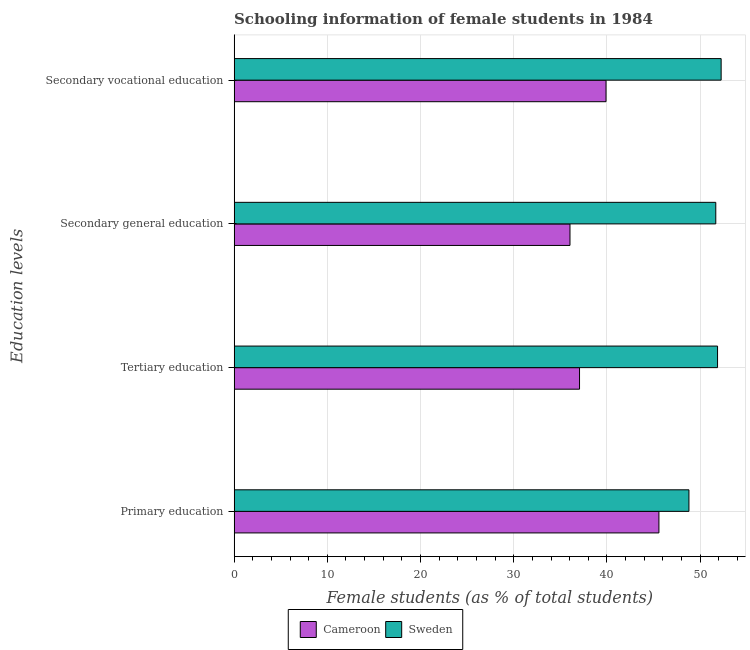How many different coloured bars are there?
Your response must be concise. 2. How many bars are there on the 1st tick from the top?
Offer a very short reply. 2. What is the label of the 2nd group of bars from the top?
Provide a succinct answer. Secondary general education. What is the percentage of female students in secondary vocational education in Cameroon?
Your answer should be very brief. 39.9. Across all countries, what is the maximum percentage of female students in primary education?
Ensure brevity in your answer.  48.8. Across all countries, what is the minimum percentage of female students in tertiary education?
Give a very brief answer. 37.06. In which country was the percentage of female students in tertiary education maximum?
Your response must be concise. Sweden. In which country was the percentage of female students in secondary vocational education minimum?
Offer a very short reply. Cameroon. What is the total percentage of female students in primary education in the graph?
Offer a terse response. 94.38. What is the difference between the percentage of female students in secondary education in Cameroon and that in Sweden?
Keep it short and to the point. -15.64. What is the difference between the percentage of female students in secondary vocational education in Cameroon and the percentage of female students in tertiary education in Sweden?
Keep it short and to the point. -11.96. What is the average percentage of female students in secondary education per country?
Give a very brief answer. 43.86. What is the difference between the percentage of female students in secondary vocational education and percentage of female students in tertiary education in Cameroon?
Your answer should be very brief. 2.84. In how many countries, is the percentage of female students in tertiary education greater than 36 %?
Keep it short and to the point. 2. What is the ratio of the percentage of female students in secondary education in Cameroon to that in Sweden?
Give a very brief answer. 0.7. What is the difference between the highest and the second highest percentage of female students in secondary education?
Your answer should be compact. 15.64. What is the difference between the highest and the lowest percentage of female students in secondary education?
Provide a short and direct response. 15.64. What does the 1st bar from the top in Tertiary education represents?
Provide a succinct answer. Sweden. What does the 1st bar from the bottom in Secondary general education represents?
Offer a terse response. Cameroon. Is it the case that in every country, the sum of the percentage of female students in primary education and percentage of female students in tertiary education is greater than the percentage of female students in secondary education?
Keep it short and to the point. Yes. How many bars are there?
Provide a short and direct response. 8. Are all the bars in the graph horizontal?
Provide a succinct answer. Yes. What is the difference between two consecutive major ticks on the X-axis?
Your answer should be compact. 10. Does the graph contain any zero values?
Provide a short and direct response. No. What is the title of the graph?
Your response must be concise. Schooling information of female students in 1984. What is the label or title of the X-axis?
Make the answer very short. Female students (as % of total students). What is the label or title of the Y-axis?
Provide a succinct answer. Education levels. What is the Female students (as % of total students) of Cameroon in Primary education?
Offer a very short reply. 45.58. What is the Female students (as % of total students) of Sweden in Primary education?
Your answer should be compact. 48.8. What is the Female students (as % of total students) of Cameroon in Tertiary education?
Your answer should be compact. 37.06. What is the Female students (as % of total students) of Sweden in Tertiary education?
Ensure brevity in your answer.  51.87. What is the Female students (as % of total students) of Cameroon in Secondary general education?
Provide a short and direct response. 36.04. What is the Female students (as % of total students) in Sweden in Secondary general education?
Offer a very short reply. 51.68. What is the Female students (as % of total students) of Cameroon in Secondary vocational education?
Your answer should be very brief. 39.9. What is the Female students (as % of total students) of Sweden in Secondary vocational education?
Provide a short and direct response. 52.25. Across all Education levels, what is the maximum Female students (as % of total students) of Cameroon?
Your response must be concise. 45.58. Across all Education levels, what is the maximum Female students (as % of total students) in Sweden?
Keep it short and to the point. 52.25. Across all Education levels, what is the minimum Female students (as % of total students) of Cameroon?
Keep it short and to the point. 36.04. Across all Education levels, what is the minimum Female students (as % of total students) in Sweden?
Keep it short and to the point. 48.8. What is the total Female students (as % of total students) in Cameroon in the graph?
Provide a short and direct response. 158.58. What is the total Female students (as % of total students) of Sweden in the graph?
Your response must be concise. 204.6. What is the difference between the Female students (as % of total students) in Cameroon in Primary education and that in Tertiary education?
Your answer should be compact. 8.52. What is the difference between the Female students (as % of total students) of Sweden in Primary education and that in Tertiary education?
Give a very brief answer. -3.07. What is the difference between the Female students (as % of total students) of Cameroon in Primary education and that in Secondary general education?
Ensure brevity in your answer.  9.54. What is the difference between the Female students (as % of total students) in Sweden in Primary education and that in Secondary general education?
Your answer should be very brief. -2.88. What is the difference between the Female students (as % of total students) of Cameroon in Primary education and that in Secondary vocational education?
Offer a terse response. 5.68. What is the difference between the Female students (as % of total students) of Sweden in Primary education and that in Secondary vocational education?
Offer a very short reply. -3.46. What is the difference between the Female students (as % of total students) in Cameroon in Tertiary education and that in Secondary general education?
Provide a short and direct response. 1.02. What is the difference between the Female students (as % of total students) in Sweden in Tertiary education and that in Secondary general education?
Make the answer very short. 0.19. What is the difference between the Female students (as % of total students) of Cameroon in Tertiary education and that in Secondary vocational education?
Offer a terse response. -2.84. What is the difference between the Female students (as % of total students) in Sweden in Tertiary education and that in Secondary vocational education?
Provide a succinct answer. -0.39. What is the difference between the Female students (as % of total students) in Cameroon in Secondary general education and that in Secondary vocational education?
Offer a very short reply. -3.87. What is the difference between the Female students (as % of total students) of Sweden in Secondary general education and that in Secondary vocational education?
Offer a terse response. -0.58. What is the difference between the Female students (as % of total students) of Cameroon in Primary education and the Female students (as % of total students) of Sweden in Tertiary education?
Keep it short and to the point. -6.29. What is the difference between the Female students (as % of total students) of Cameroon in Primary education and the Female students (as % of total students) of Sweden in Secondary general education?
Keep it short and to the point. -6.1. What is the difference between the Female students (as % of total students) in Cameroon in Primary education and the Female students (as % of total students) in Sweden in Secondary vocational education?
Ensure brevity in your answer.  -6.68. What is the difference between the Female students (as % of total students) in Cameroon in Tertiary education and the Female students (as % of total students) in Sweden in Secondary general education?
Provide a succinct answer. -14.62. What is the difference between the Female students (as % of total students) of Cameroon in Tertiary education and the Female students (as % of total students) of Sweden in Secondary vocational education?
Your answer should be compact. -15.19. What is the difference between the Female students (as % of total students) of Cameroon in Secondary general education and the Female students (as % of total students) of Sweden in Secondary vocational education?
Give a very brief answer. -16.22. What is the average Female students (as % of total students) of Cameroon per Education levels?
Your answer should be very brief. 39.64. What is the average Female students (as % of total students) of Sweden per Education levels?
Ensure brevity in your answer.  51.15. What is the difference between the Female students (as % of total students) of Cameroon and Female students (as % of total students) of Sweden in Primary education?
Make the answer very short. -3.22. What is the difference between the Female students (as % of total students) of Cameroon and Female students (as % of total students) of Sweden in Tertiary education?
Give a very brief answer. -14.81. What is the difference between the Female students (as % of total students) in Cameroon and Female students (as % of total students) in Sweden in Secondary general education?
Your answer should be very brief. -15.64. What is the difference between the Female students (as % of total students) of Cameroon and Female students (as % of total students) of Sweden in Secondary vocational education?
Your response must be concise. -12.35. What is the ratio of the Female students (as % of total students) of Cameroon in Primary education to that in Tertiary education?
Your answer should be compact. 1.23. What is the ratio of the Female students (as % of total students) of Sweden in Primary education to that in Tertiary education?
Your response must be concise. 0.94. What is the ratio of the Female students (as % of total students) in Cameroon in Primary education to that in Secondary general education?
Your answer should be very brief. 1.26. What is the ratio of the Female students (as % of total students) in Sweden in Primary education to that in Secondary general education?
Keep it short and to the point. 0.94. What is the ratio of the Female students (as % of total students) in Cameroon in Primary education to that in Secondary vocational education?
Your answer should be very brief. 1.14. What is the ratio of the Female students (as % of total students) in Sweden in Primary education to that in Secondary vocational education?
Your answer should be compact. 0.93. What is the ratio of the Female students (as % of total students) in Cameroon in Tertiary education to that in Secondary general education?
Your response must be concise. 1.03. What is the ratio of the Female students (as % of total students) in Sweden in Tertiary education to that in Secondary general education?
Ensure brevity in your answer.  1. What is the ratio of the Female students (as % of total students) of Cameroon in Tertiary education to that in Secondary vocational education?
Provide a succinct answer. 0.93. What is the ratio of the Female students (as % of total students) of Sweden in Tertiary education to that in Secondary vocational education?
Provide a short and direct response. 0.99. What is the ratio of the Female students (as % of total students) in Cameroon in Secondary general education to that in Secondary vocational education?
Give a very brief answer. 0.9. What is the ratio of the Female students (as % of total students) of Sweden in Secondary general education to that in Secondary vocational education?
Offer a very short reply. 0.99. What is the difference between the highest and the second highest Female students (as % of total students) in Cameroon?
Your response must be concise. 5.68. What is the difference between the highest and the second highest Female students (as % of total students) in Sweden?
Provide a short and direct response. 0.39. What is the difference between the highest and the lowest Female students (as % of total students) in Cameroon?
Provide a succinct answer. 9.54. What is the difference between the highest and the lowest Female students (as % of total students) in Sweden?
Ensure brevity in your answer.  3.46. 